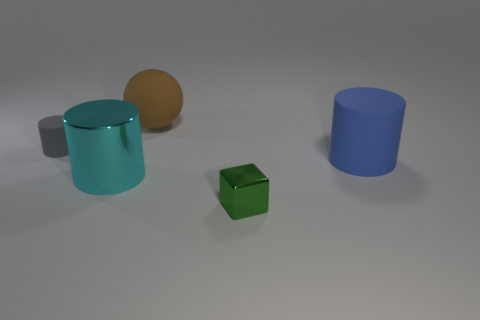There is a matte thing that is to the right of the green metallic thing; is it the same size as the brown ball?
Provide a succinct answer. Yes. What is the color of the metallic cylinder that is the same size as the brown rubber object?
Provide a succinct answer. Cyan. How many big cyan objects are left of the cyan cylinder?
Provide a succinct answer. 0. Is there a large thing?
Offer a terse response. Yes. There is a cylinder that is in front of the big blue cylinder that is right of the large shiny cylinder that is behind the cube; what size is it?
Provide a short and direct response. Large. What number of other things are the same size as the rubber sphere?
Your response must be concise. 2. How big is the cyan object that is in front of the brown rubber ball?
Your answer should be very brief. Large. Is there anything else that is the same color as the small cylinder?
Your response must be concise. No. Is the material of the large cylinder that is on the left side of the tiny cube the same as the tiny cube?
Give a very brief answer. Yes. How many big things are behind the cyan metallic object and in front of the sphere?
Ensure brevity in your answer.  1. 